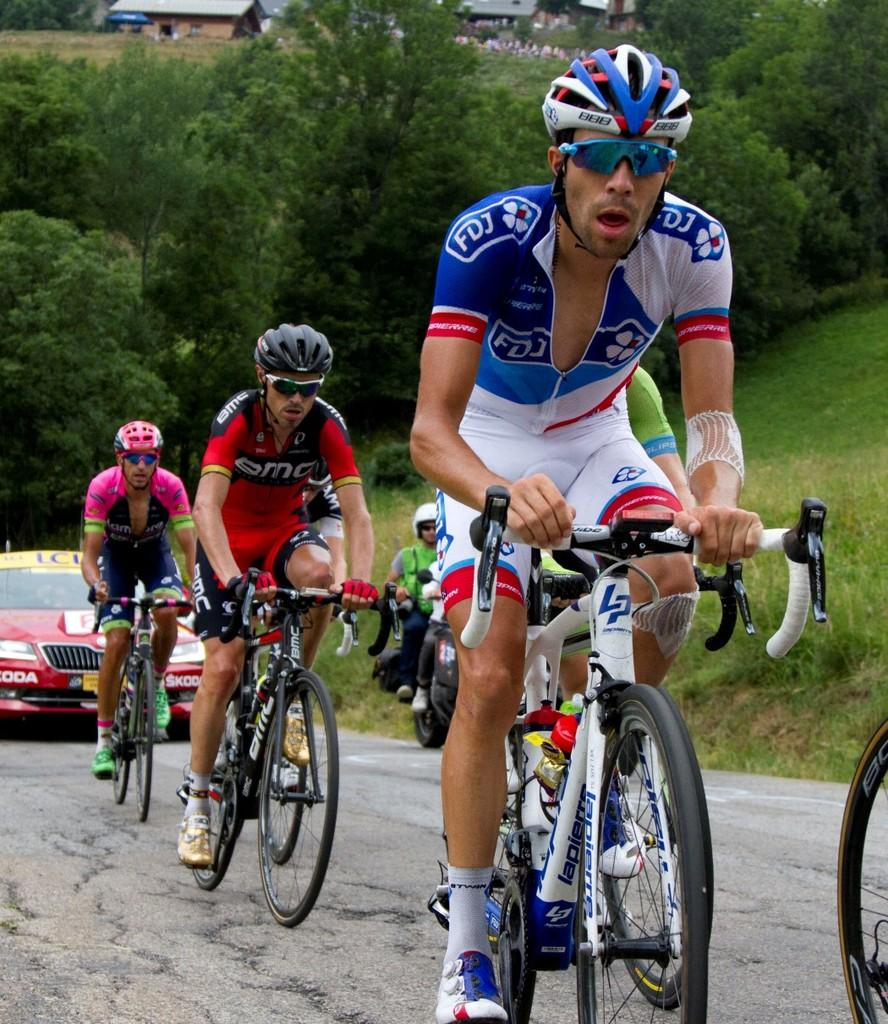What are the people in the image doing? The people in the image are riding bicycles. What other mode of transportation can be seen in the image? There is a car in the image. What type of natural environment is visible in the image? There is grass and trees in the image. What can be seen in the background of the image? There are houses in the background of the image. How many giants are visible in the image? There are no giants present in the image. What type of hat is the person on the bicycle wearing? There is no hat mentioned or visible in the image. 